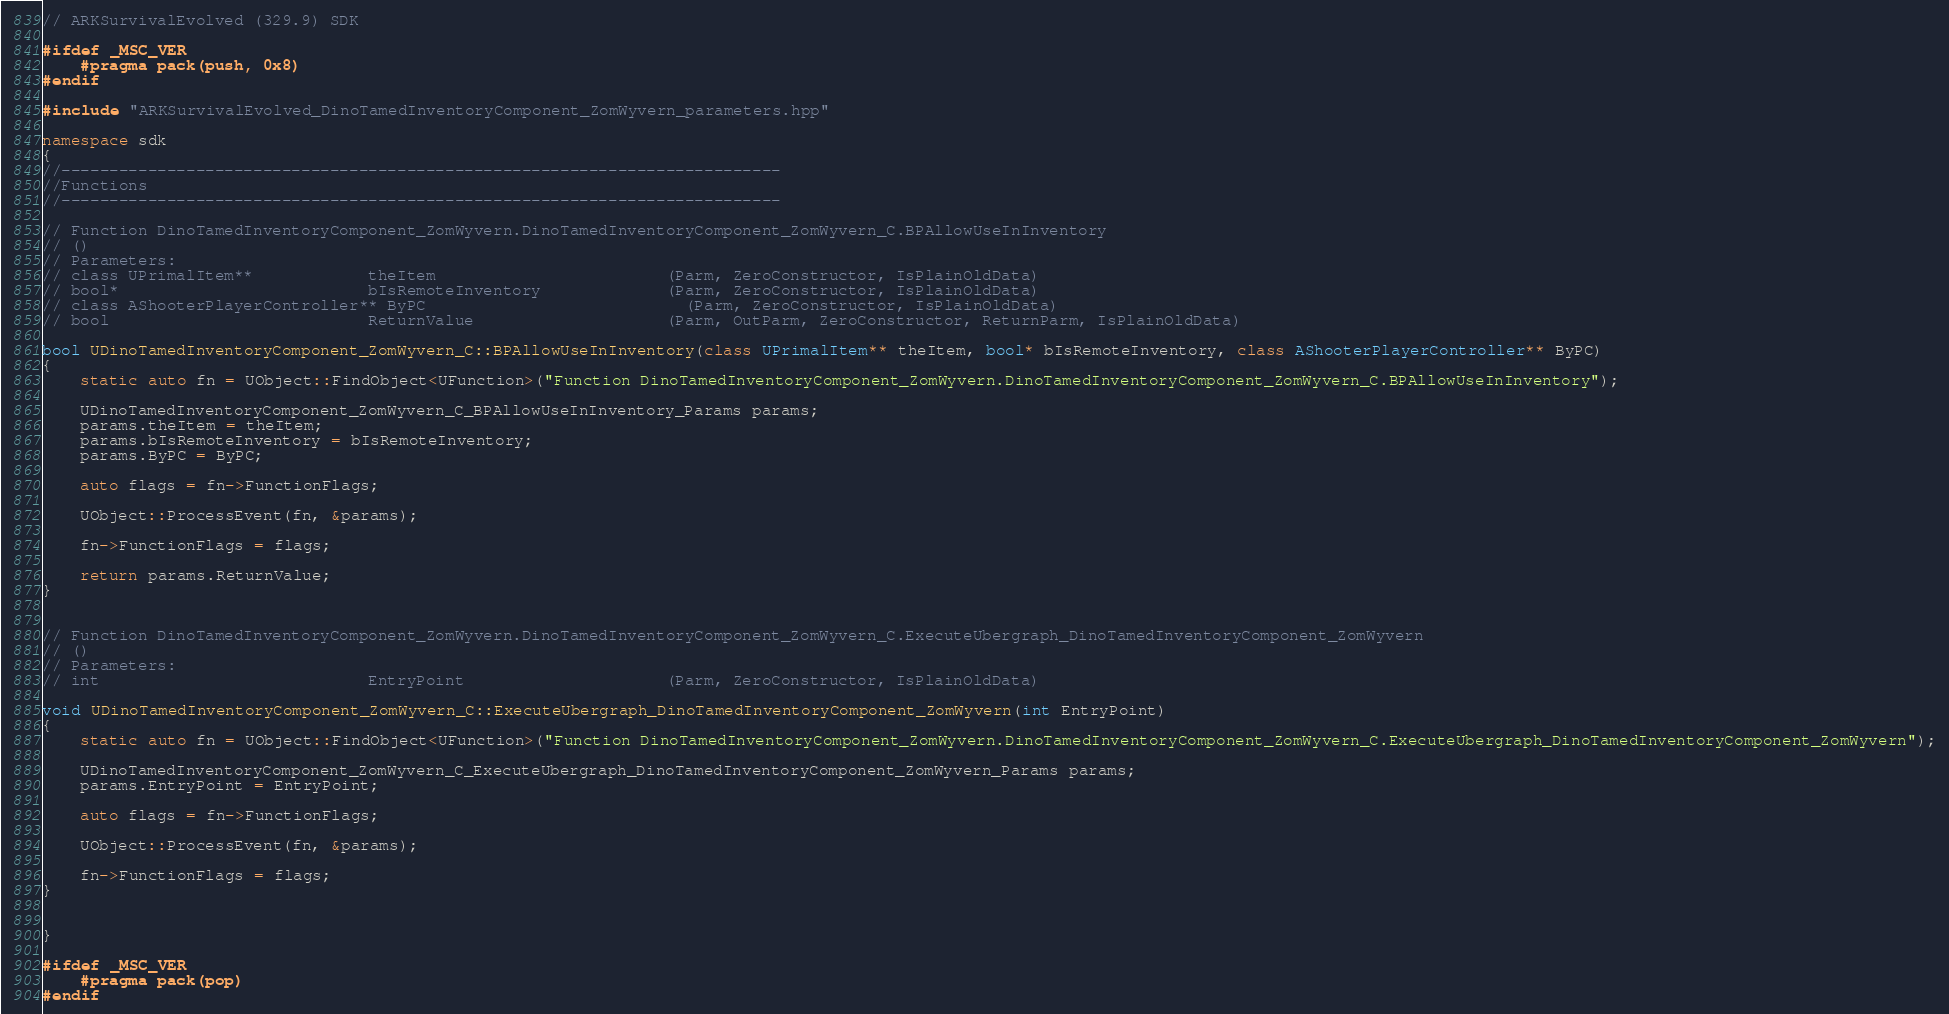Convert code to text. <code><loc_0><loc_0><loc_500><loc_500><_C++_>// ARKSurvivalEvolved (329.9) SDK

#ifdef _MSC_VER
	#pragma pack(push, 0x8)
#endif

#include "ARKSurvivalEvolved_DinoTamedInventoryComponent_ZomWyvern_parameters.hpp"

namespace sdk
{
//---------------------------------------------------------------------------
//Functions
//---------------------------------------------------------------------------

// Function DinoTamedInventoryComponent_ZomWyvern.DinoTamedInventoryComponent_ZomWyvern_C.BPAllowUseInInventory
// ()
// Parameters:
// class UPrimalItem**            theItem                        (Parm, ZeroConstructor, IsPlainOldData)
// bool*                          bIsRemoteInventory             (Parm, ZeroConstructor, IsPlainOldData)
// class AShooterPlayerController** ByPC                           (Parm, ZeroConstructor, IsPlainOldData)
// bool                           ReturnValue                    (Parm, OutParm, ZeroConstructor, ReturnParm, IsPlainOldData)

bool UDinoTamedInventoryComponent_ZomWyvern_C::BPAllowUseInInventory(class UPrimalItem** theItem, bool* bIsRemoteInventory, class AShooterPlayerController** ByPC)
{
	static auto fn = UObject::FindObject<UFunction>("Function DinoTamedInventoryComponent_ZomWyvern.DinoTamedInventoryComponent_ZomWyvern_C.BPAllowUseInInventory");

	UDinoTamedInventoryComponent_ZomWyvern_C_BPAllowUseInInventory_Params params;
	params.theItem = theItem;
	params.bIsRemoteInventory = bIsRemoteInventory;
	params.ByPC = ByPC;

	auto flags = fn->FunctionFlags;

	UObject::ProcessEvent(fn, &params);

	fn->FunctionFlags = flags;

	return params.ReturnValue;
}


// Function DinoTamedInventoryComponent_ZomWyvern.DinoTamedInventoryComponent_ZomWyvern_C.ExecuteUbergraph_DinoTamedInventoryComponent_ZomWyvern
// ()
// Parameters:
// int                            EntryPoint                     (Parm, ZeroConstructor, IsPlainOldData)

void UDinoTamedInventoryComponent_ZomWyvern_C::ExecuteUbergraph_DinoTamedInventoryComponent_ZomWyvern(int EntryPoint)
{
	static auto fn = UObject::FindObject<UFunction>("Function DinoTamedInventoryComponent_ZomWyvern.DinoTamedInventoryComponent_ZomWyvern_C.ExecuteUbergraph_DinoTamedInventoryComponent_ZomWyvern");

	UDinoTamedInventoryComponent_ZomWyvern_C_ExecuteUbergraph_DinoTamedInventoryComponent_ZomWyvern_Params params;
	params.EntryPoint = EntryPoint;

	auto flags = fn->FunctionFlags;

	UObject::ProcessEvent(fn, &params);

	fn->FunctionFlags = flags;
}


}

#ifdef _MSC_VER
	#pragma pack(pop)
#endif
</code> 